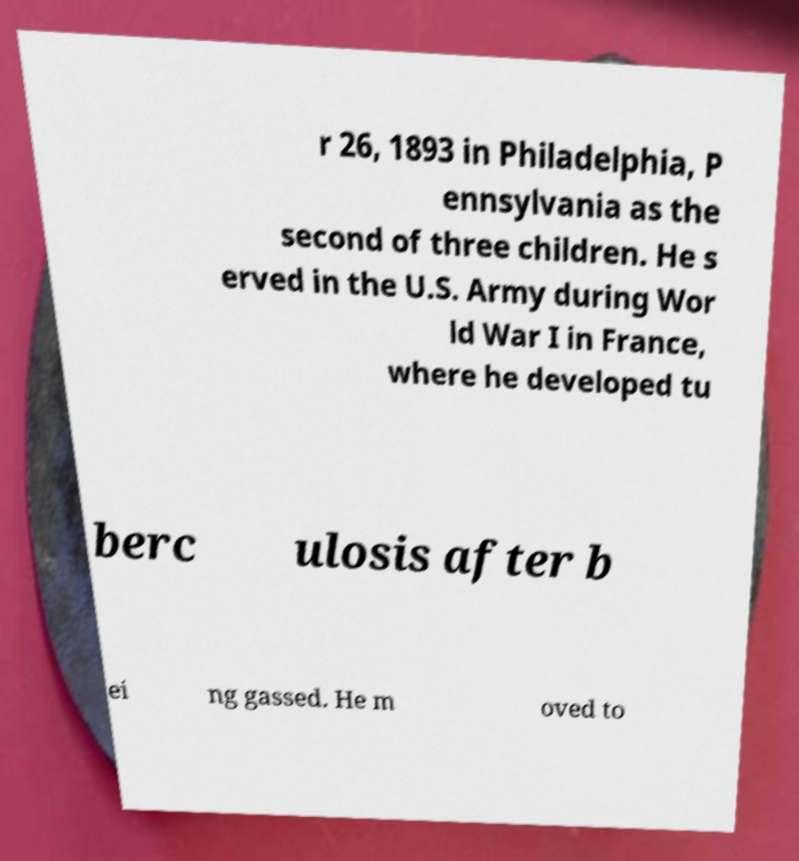Please identify and transcribe the text found in this image. r 26, 1893 in Philadelphia, P ennsylvania as the second of three children. He s erved in the U.S. Army during Wor ld War I in France, where he developed tu berc ulosis after b ei ng gassed. He m oved to 